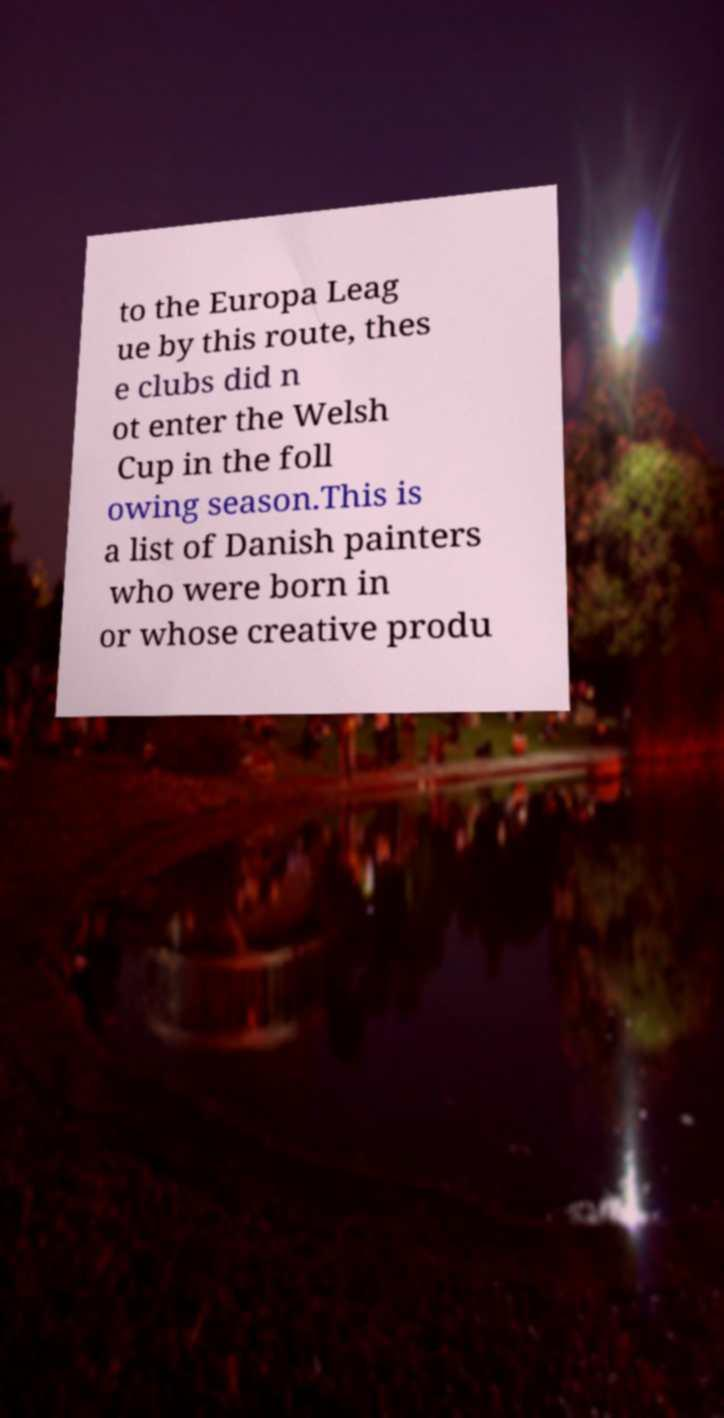Please read and relay the text visible in this image. What does it say? to the Europa Leag ue by this route, thes e clubs did n ot enter the Welsh Cup in the foll owing season.This is a list of Danish painters who were born in or whose creative produ 